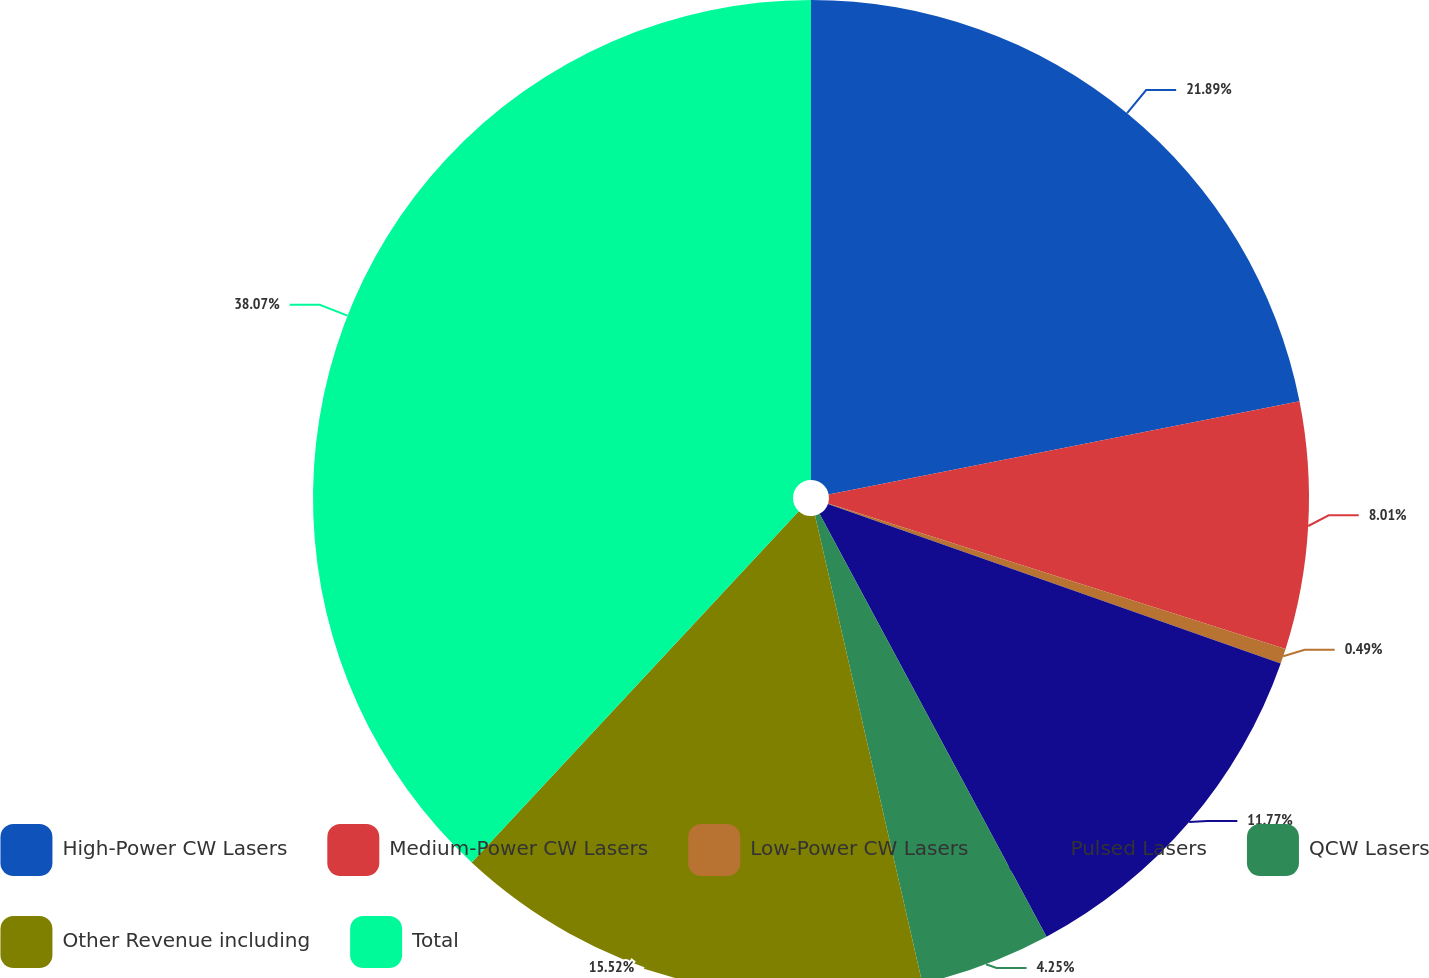<chart> <loc_0><loc_0><loc_500><loc_500><pie_chart><fcel>High-Power CW Lasers<fcel>Medium-Power CW Lasers<fcel>Low-Power CW Lasers<fcel>Pulsed Lasers<fcel>QCW Lasers<fcel>Other Revenue including<fcel>Total<nl><fcel>21.89%<fcel>8.01%<fcel>0.49%<fcel>11.77%<fcel>4.25%<fcel>15.52%<fcel>38.07%<nl></chart> 